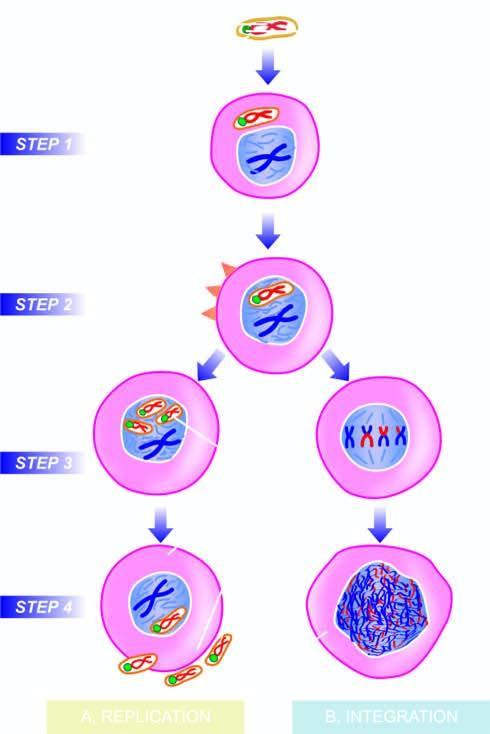what are assembled in the cell nucleus?
Answer the question using a single word or phrase. New virions 